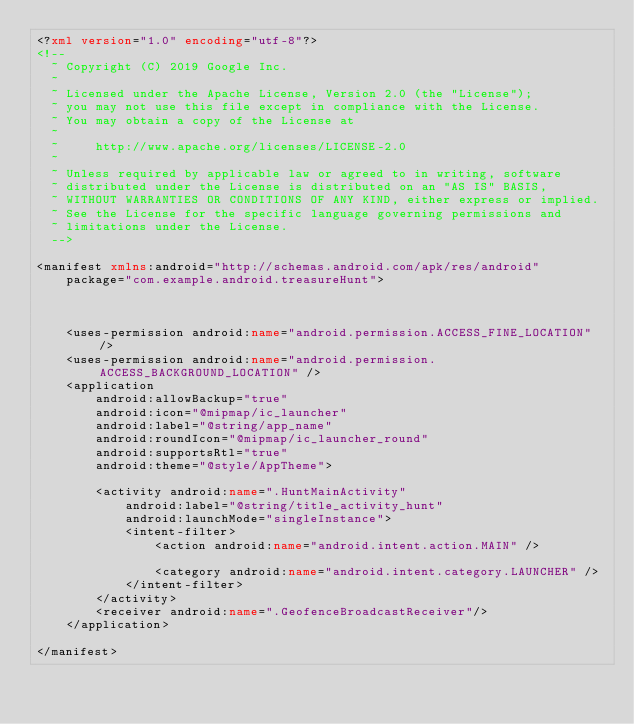Convert code to text. <code><loc_0><loc_0><loc_500><loc_500><_XML_><?xml version="1.0" encoding="utf-8"?>
<!--
  ~ Copyright (C) 2019 Google Inc.
  ~
  ~ Licensed under the Apache License, Version 2.0 (the "License");
  ~ you may not use this file except in compliance with the License.
  ~ You may obtain a copy of the License at
  ~
  ~     http://www.apache.org/licenses/LICENSE-2.0
  ~
  ~ Unless required by applicable law or agreed to in writing, software
  ~ distributed under the License is distributed on an "AS IS" BASIS,
  ~ WITHOUT WARRANTIES OR CONDITIONS OF ANY KIND, either express or implied.
  ~ See the License for the specific language governing permissions and
  ~ limitations under the License.
  -->

<manifest xmlns:android="http://schemas.android.com/apk/res/android"
    package="com.example.android.treasureHunt">



    <uses-permission android:name="android.permission.ACCESS_FINE_LOCATION" />
    <uses-permission android:name="android.permission.ACCESS_BACKGROUND_LOCATION" />
    <application
        android:allowBackup="true"
        android:icon="@mipmap/ic_launcher"
        android:label="@string/app_name"
        android:roundIcon="@mipmap/ic_launcher_round"
        android:supportsRtl="true"
        android:theme="@style/AppTheme">

        <activity android:name=".HuntMainActivity"
            android:label="@string/title_activity_hunt"
            android:launchMode="singleInstance">
            <intent-filter>
                <action android:name="android.intent.action.MAIN" />

                <category android:name="android.intent.category.LAUNCHER" />
            </intent-filter>
        </activity>
        <receiver android:name=".GeofenceBroadcastReceiver"/>
    </application>

</manifest>
</code> 